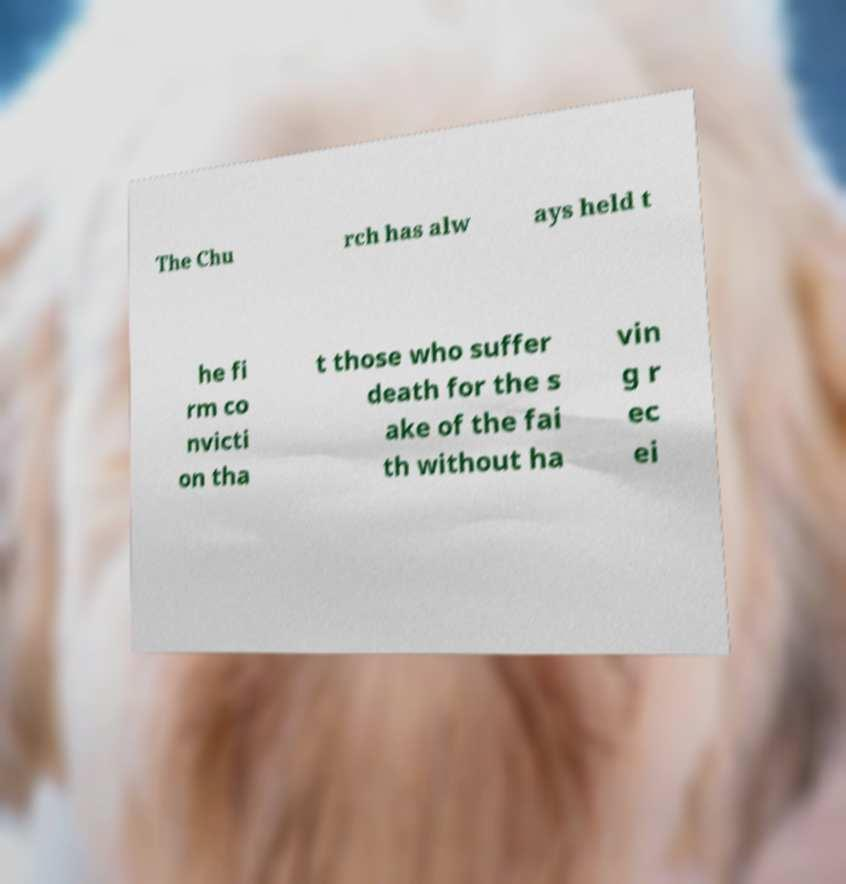Please identify and transcribe the text found in this image. The Chu rch has alw ays held t he fi rm co nvicti on tha t those who suffer death for the s ake of the fai th without ha vin g r ec ei 